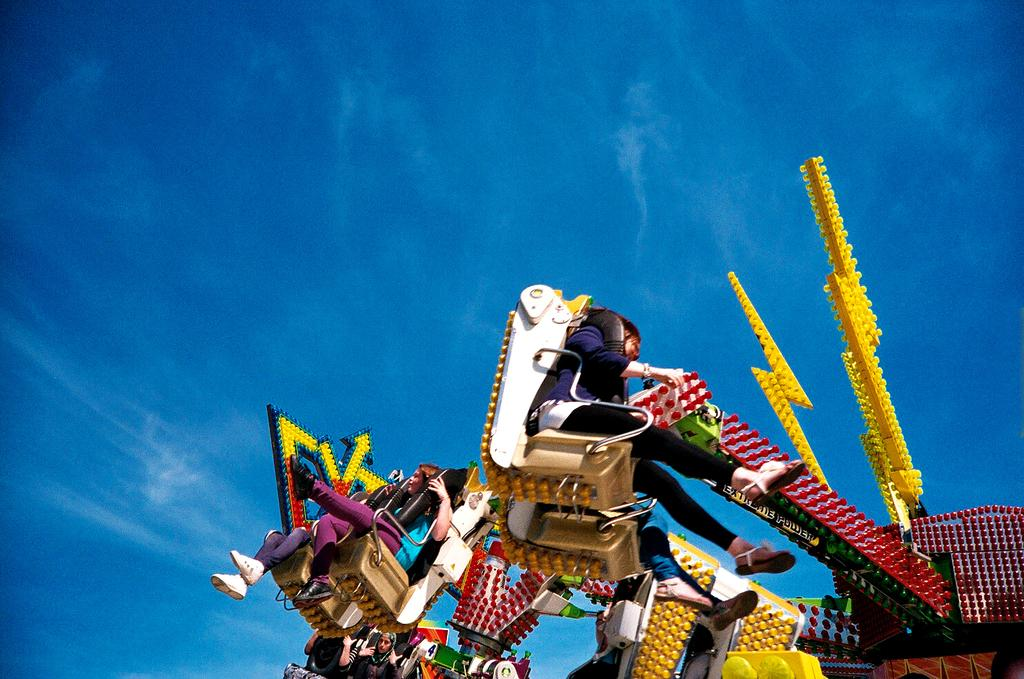What type of setting is depicted in the image? The image is an outside view. What are the people in the image doing? The people are sitting in a vehicle. What kind of vehicle is the people sitting in? The vehicle appears to be an amusement ride. What can be seen in the sky in the image? The sky is visible at the top of the image. What type of cloth is draped over the tray in the image? There is no cloth or tray present in the image. What is the opinion of the people sitting in the vehicle about the ride? The image does not provide any information about the people's opinions, so it cannot be determined from the image. 